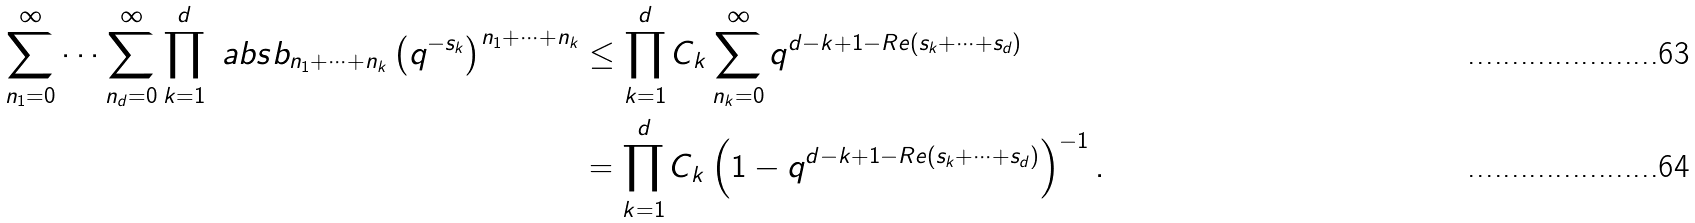Convert formula to latex. <formula><loc_0><loc_0><loc_500><loc_500>\sum _ { n _ { 1 } = 0 } ^ { \infty } \cdots \sum _ { n _ { d } = 0 } ^ { \infty } \prod _ { k = 1 } ^ { d } \ a b s { b _ { n _ { 1 } + \cdots + n _ { k } } \left ( q ^ { - s _ { k } } \right ) ^ { n _ { 1 } + \cdots + n _ { k } } } & \leq \prod _ { k = 1 } ^ { d } C _ { k } \sum _ { n _ { k } = 0 } ^ { \infty } q ^ { d - k + 1 - R e ( s _ { k } + \cdots + s _ { d } ) } \\ & = \prod _ { k = 1 } ^ { d } C _ { k } \left ( 1 - q ^ { d - k + 1 - R e ( s _ { k } + \cdots + s _ { d } ) } \right ) ^ { - 1 } .</formula> 